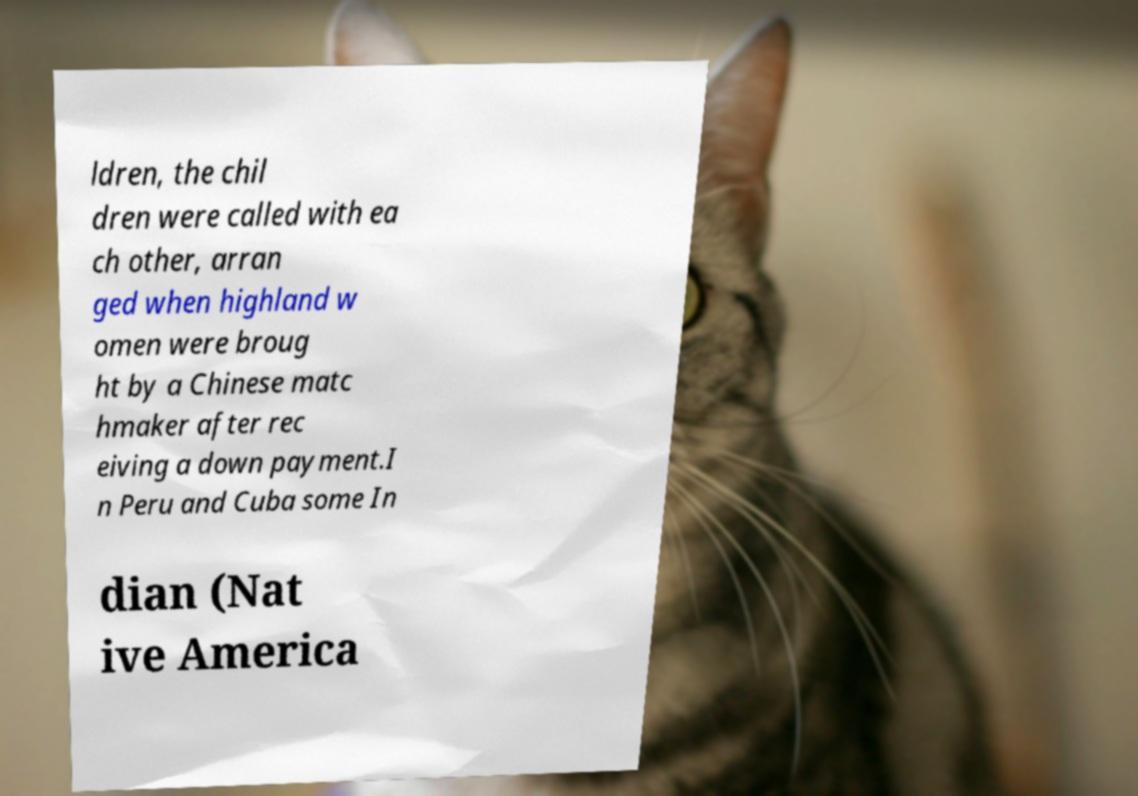Can you accurately transcribe the text from the provided image for me? ldren, the chil dren were called with ea ch other, arran ged when highland w omen were broug ht by a Chinese matc hmaker after rec eiving a down payment.I n Peru and Cuba some In dian (Nat ive America 